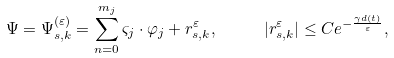Convert formula to latex. <formula><loc_0><loc_0><loc_500><loc_500>\Psi = \Psi _ { s , k } ^ { ( \varepsilon ) } = \sum _ { n = 0 } ^ { m _ { j } } \varsigma _ { j } \cdot \varphi _ { j } + r _ { s , k } ^ { \varepsilon } , \text { \quad } | r _ { s , k } ^ { \varepsilon } | \leq C e ^ { - \frac { \gamma d ( t ) } { \varepsilon } } ,</formula> 